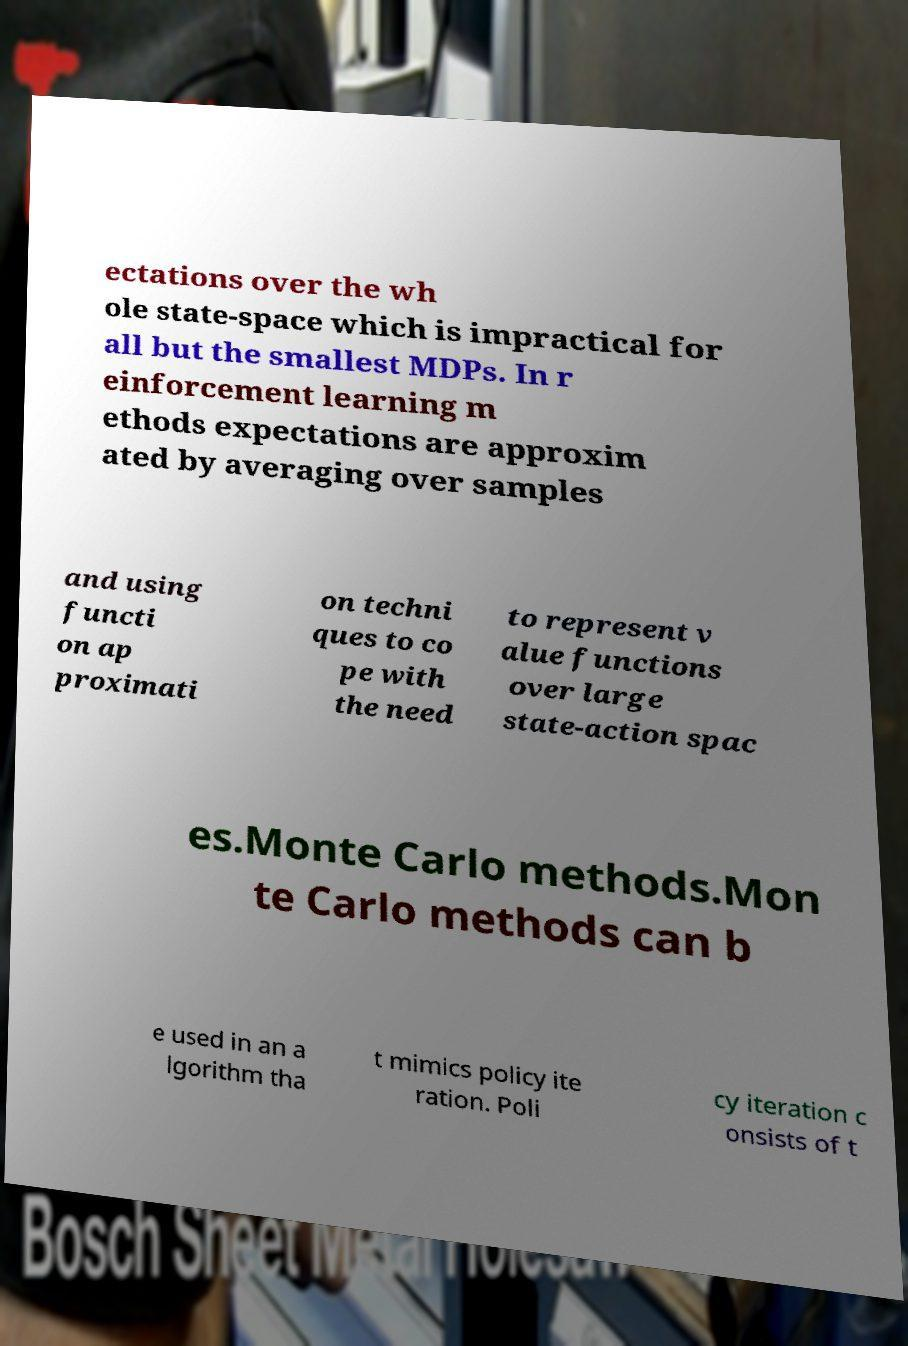Please identify and transcribe the text found in this image. ectations over the wh ole state-space which is impractical for all but the smallest MDPs. In r einforcement learning m ethods expectations are approxim ated by averaging over samples and using functi on ap proximati on techni ques to co pe with the need to represent v alue functions over large state-action spac es.Monte Carlo methods.Mon te Carlo methods can b e used in an a lgorithm tha t mimics policy ite ration. Poli cy iteration c onsists of t 